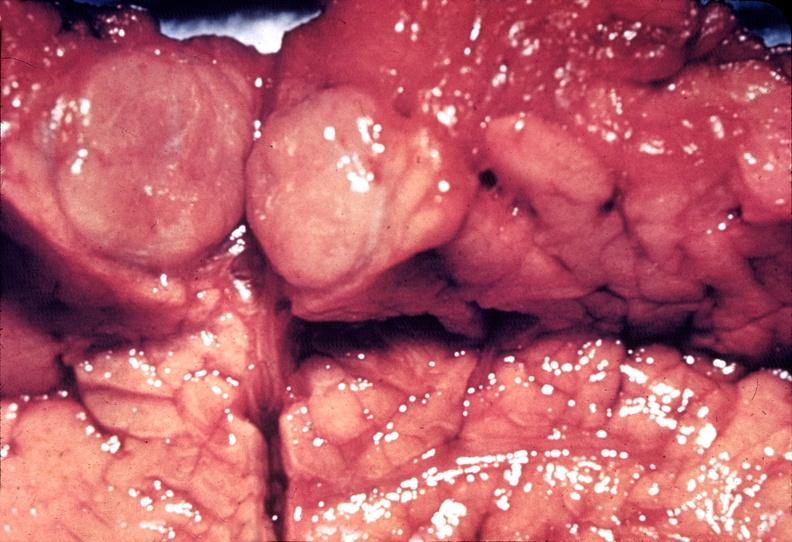s pancreas present?
Answer the question using a single word or phrase. Yes 